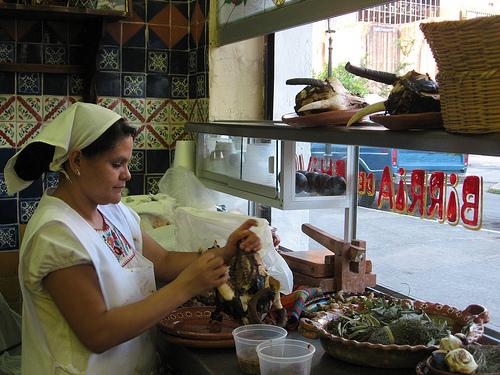<image>
Is the basket to the left of the plate? No. The basket is not to the left of the plate. From this viewpoint, they have a different horizontal relationship. Where is the woman in relation to the tile? Is it behind the tile? No. The woman is not behind the tile. From this viewpoint, the woman appears to be positioned elsewhere in the scene. 